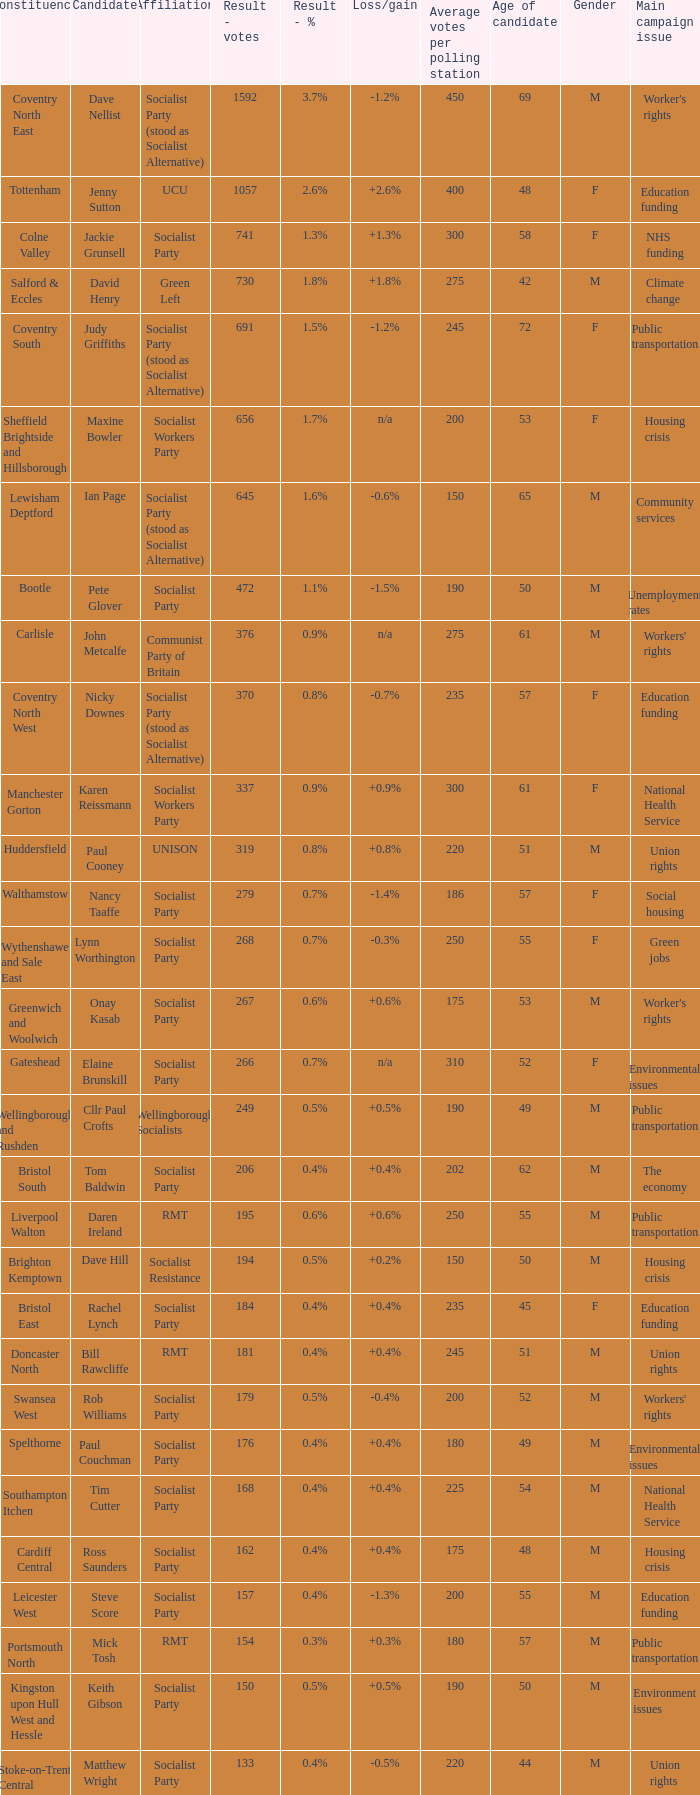What is every affiliation for the Tottenham constituency? UCU. 